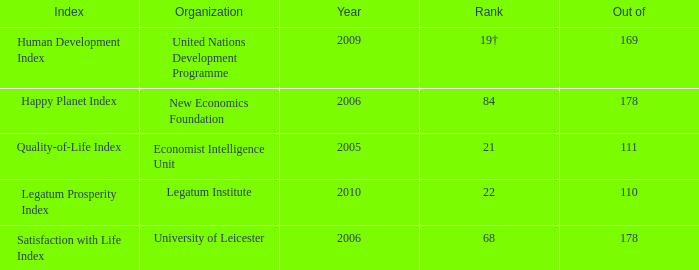What organization ranks 68? University of Leicester. 